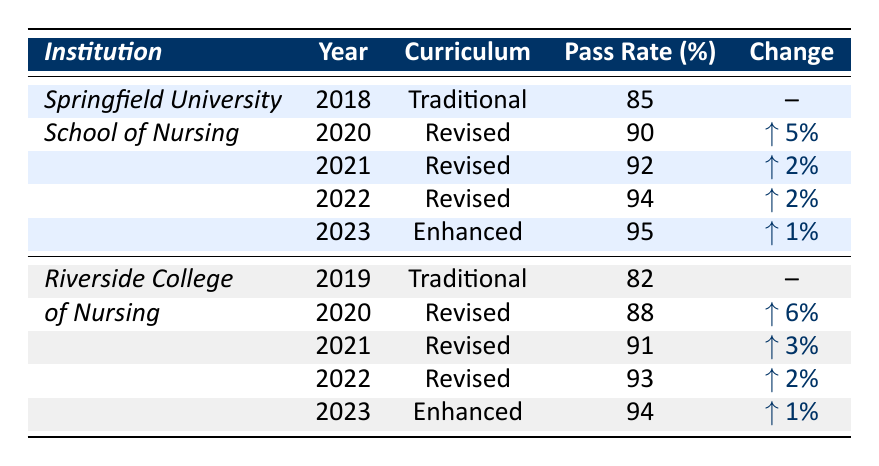What was the pass rate for Springfield University in 2019? The pass rate for Springfield University is not listed for 2019 because it only shows data for the Traditional Curriculum in 2018 and the Revised Curriculum starting in 2020.
Answer: Not applicable What was the highest pass rate for Riverside College of Nursing? The highest pass rate for Riverside College of Nursing in the table was 94% in the year 2023 with the Enhanced Curriculum.
Answer: 94% Did Springfield University show an improvement in pass rates every year from 2020 to 2023? Yes, Springfield University's pass rates increased from 90% in 2020 to 95% in 2023 without any declines in between.
Answer: Yes What is the difference in pass rates for Riverside College of Nursing between 2019 and 2022? The pass rate for Riverside College of Nursing in 2019 was 82% and 93% in 2022. The difference is 93% - 82% = 11%.
Answer: 11% What was the average pass rate for the Revised Curriculum years at Springfield University? The pass rates for Springfield University with the Revised Curriculum are 90% (2020), 92% (2021), and 94% (2022). The average is (90 + 92 + 94) / 3 = 92%.
Answer: 92% Which institution had a higher pass rate in 2020, Springfield University or Riverside College of Nursing? Springfield University had a pass rate of 90% in 2020, while Riverside College of Nursing had a pass rate of 88%. Since 90% is greater than 88%, Springfield University had the higher rate.
Answer: Springfield University How much did the pass rate increase for the Enhanced Curriculum at Springfield University from 2022 to 2023? The pass rate for Springfield University in 2022 was 94%, and in 2023 it was 95%. The increase is 95% - 94% = 1%.
Answer: 1% Did any institution achieve a pass rate of over 90% in 2019? Riverside College of Nursing had a pass rate of 82% in 2019, which is not over 90%. Therefore, none of the institutions achieved over 90% that year.
Answer: No What was the cumulative increase in pass rates for Riverside College of Nursing from 2019 through 2023? The pass rates for Riverside College are 82% (2019), 88% (2020), 91% (2021), 93% (2022), and 94% (2023). The cumulative increase is: 88 - 82 = 6, 91 - 88 = 3, 93 - 91 = 2, 94 - 93 = 1. Summing these changes: 6 + 3 + 2 + 1 = 12%.
Answer: 12% Which curriculum had the highest pass rate in 2023? In 2023, the Enhanced Curriculum had a pass rate of 95% at Springfield University, which was the highest compared to Riverside College's pass rate of 94%.
Answer: Enhanced Curriculum 